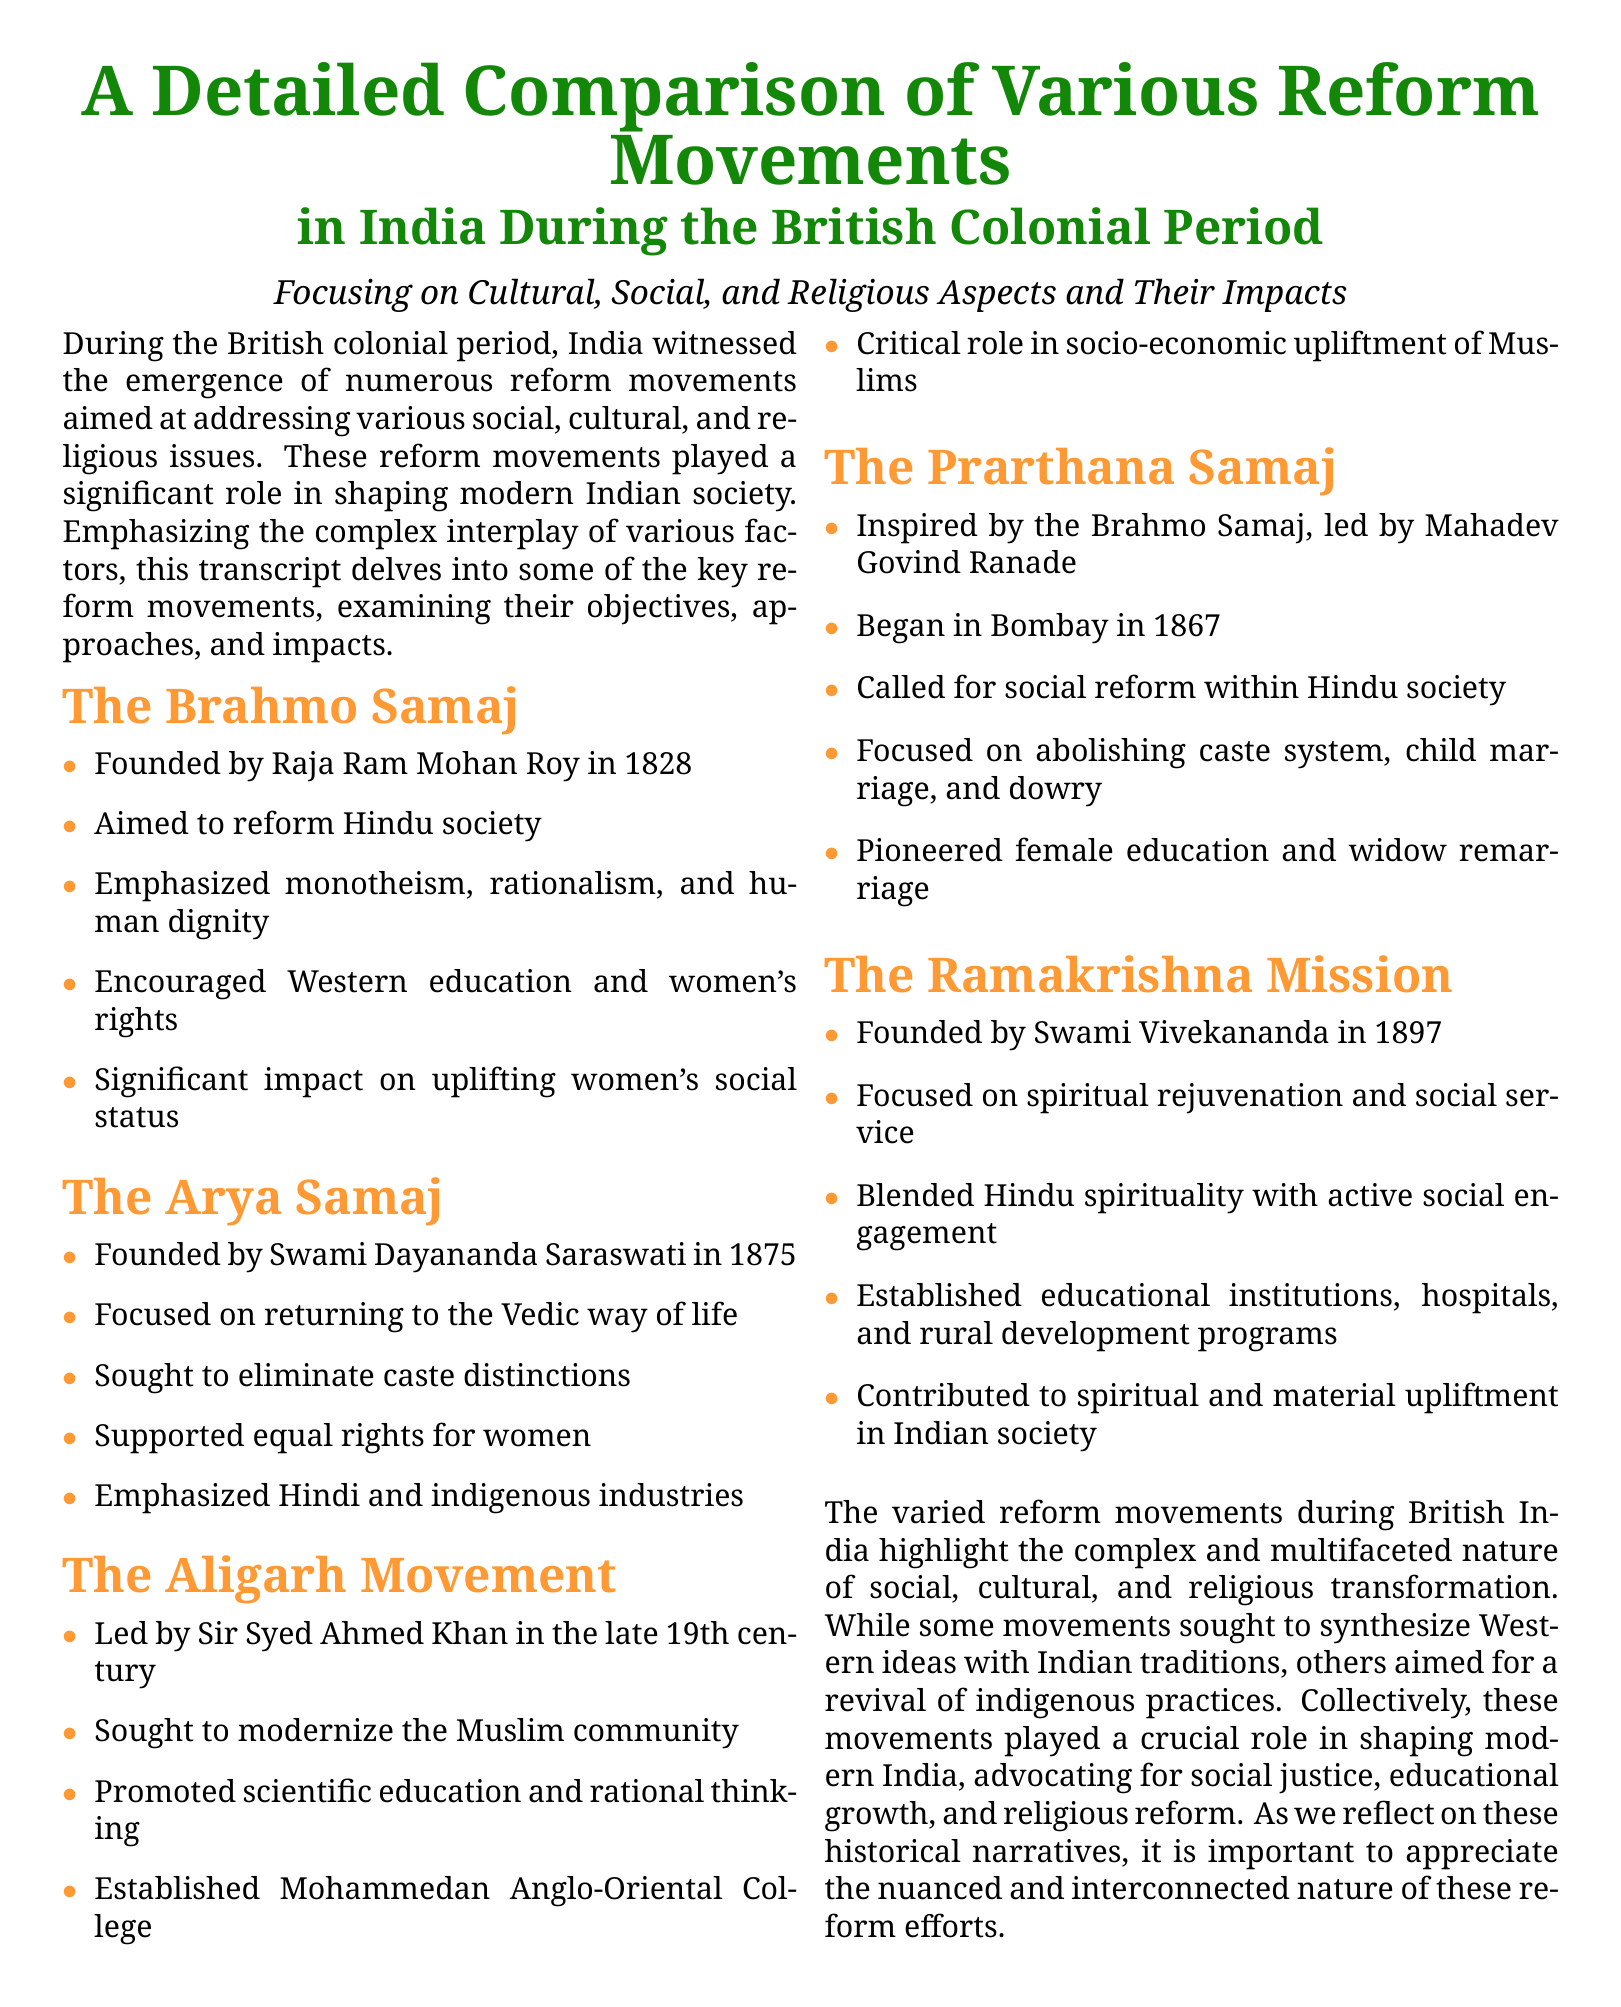What year was the Brahmo Samaj founded? The document states that the Brahmo Samaj was founded in 1828 by Raja Ram Mohan Roy.
Answer: 1828 Who founded the Arya Samaj? The Arya Samaj was founded by Swami Dayananda Saraswati as mentioned in the document.
Answer: Swami Dayananda Saraswati What was the main goal of the Aligarh Movement? The document outlines that the main goal of the Aligarh Movement was to modernize the Muslim community.
Answer: Modernize the Muslim community Which reform movement was led by Mahadev Govind Ranade? Mahadev Govind Ranade led the Prarthana Samaj according to the document.
Answer: Prarthana Samaj What year was the Ramakrishna Mission founded? The Ramakrishna Mission was founded by Swami Vivekananda in 1897 as per the document.
Answer: 1897 How many reform movements are discussed in the document? The document discusses five specific reform movements during the British colonial period.
Answer: Five What aspect did the Arya Samaj emphasize in its reform efforts? The document states that the Arya Samaj emphasized returning to the Vedic way of life.
Answer: Vedic way of life Which college was established by the Aligarh Movement? As mentioned in the document, the Aligarh Movement established the Mohammedan Anglo-Oriental College.
Answer: Mohammedan Anglo-Oriental College What social issue did the Prarthana Samaj focus on abolishing? The document highlights that the Prarthana Samaj focused on abolishing the caste system.
Answer: Caste system 